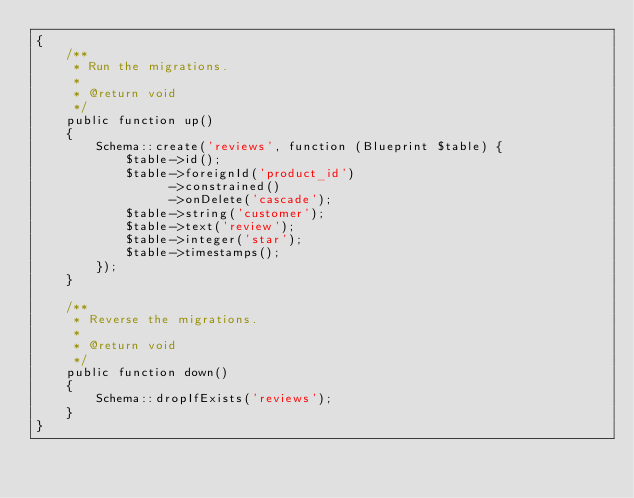<code> <loc_0><loc_0><loc_500><loc_500><_PHP_>{
    /**
     * Run the migrations.
     *
     * @return void
     */
    public function up()
    {
        Schema::create('reviews', function (Blueprint $table) {
            $table->id();
            $table->foreignId('product_id')
                  ->constrained()
                  ->onDelete('cascade');
            $table->string('customer');
            $table->text('review');
            $table->integer('star');
            $table->timestamps();
        });
    }

    /**
     * Reverse the migrations.
     *
     * @return void
     */
    public function down()
    {
        Schema::dropIfExists('reviews');
    }
}
</code> 